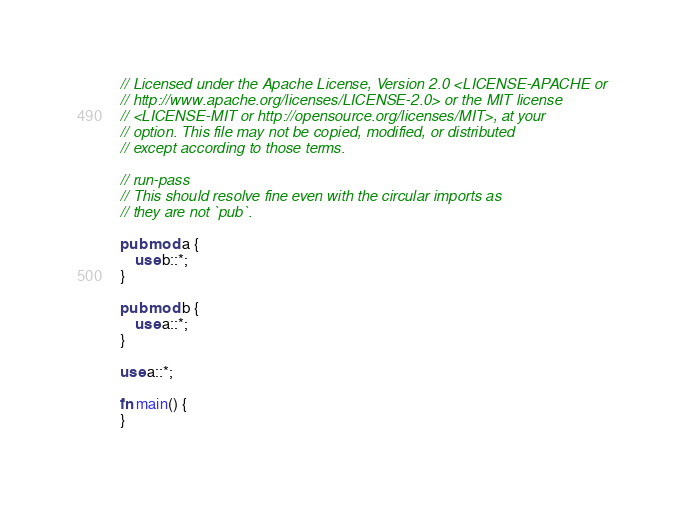Convert code to text. <code><loc_0><loc_0><loc_500><loc_500><_Rust_>// Licensed under the Apache License, Version 2.0 <LICENSE-APACHE or
// http://www.apache.org/licenses/LICENSE-2.0> or the MIT license
// <LICENSE-MIT or http://opensource.org/licenses/MIT>, at your
// option. This file may not be copied, modified, or distributed
// except according to those terms.

// run-pass
// This should resolve fine even with the circular imports as
// they are not `pub`.

pub mod a {
    use b::*;
}

pub mod b {
    use a::*;
}

use a::*;

fn main() {
}
</code> 